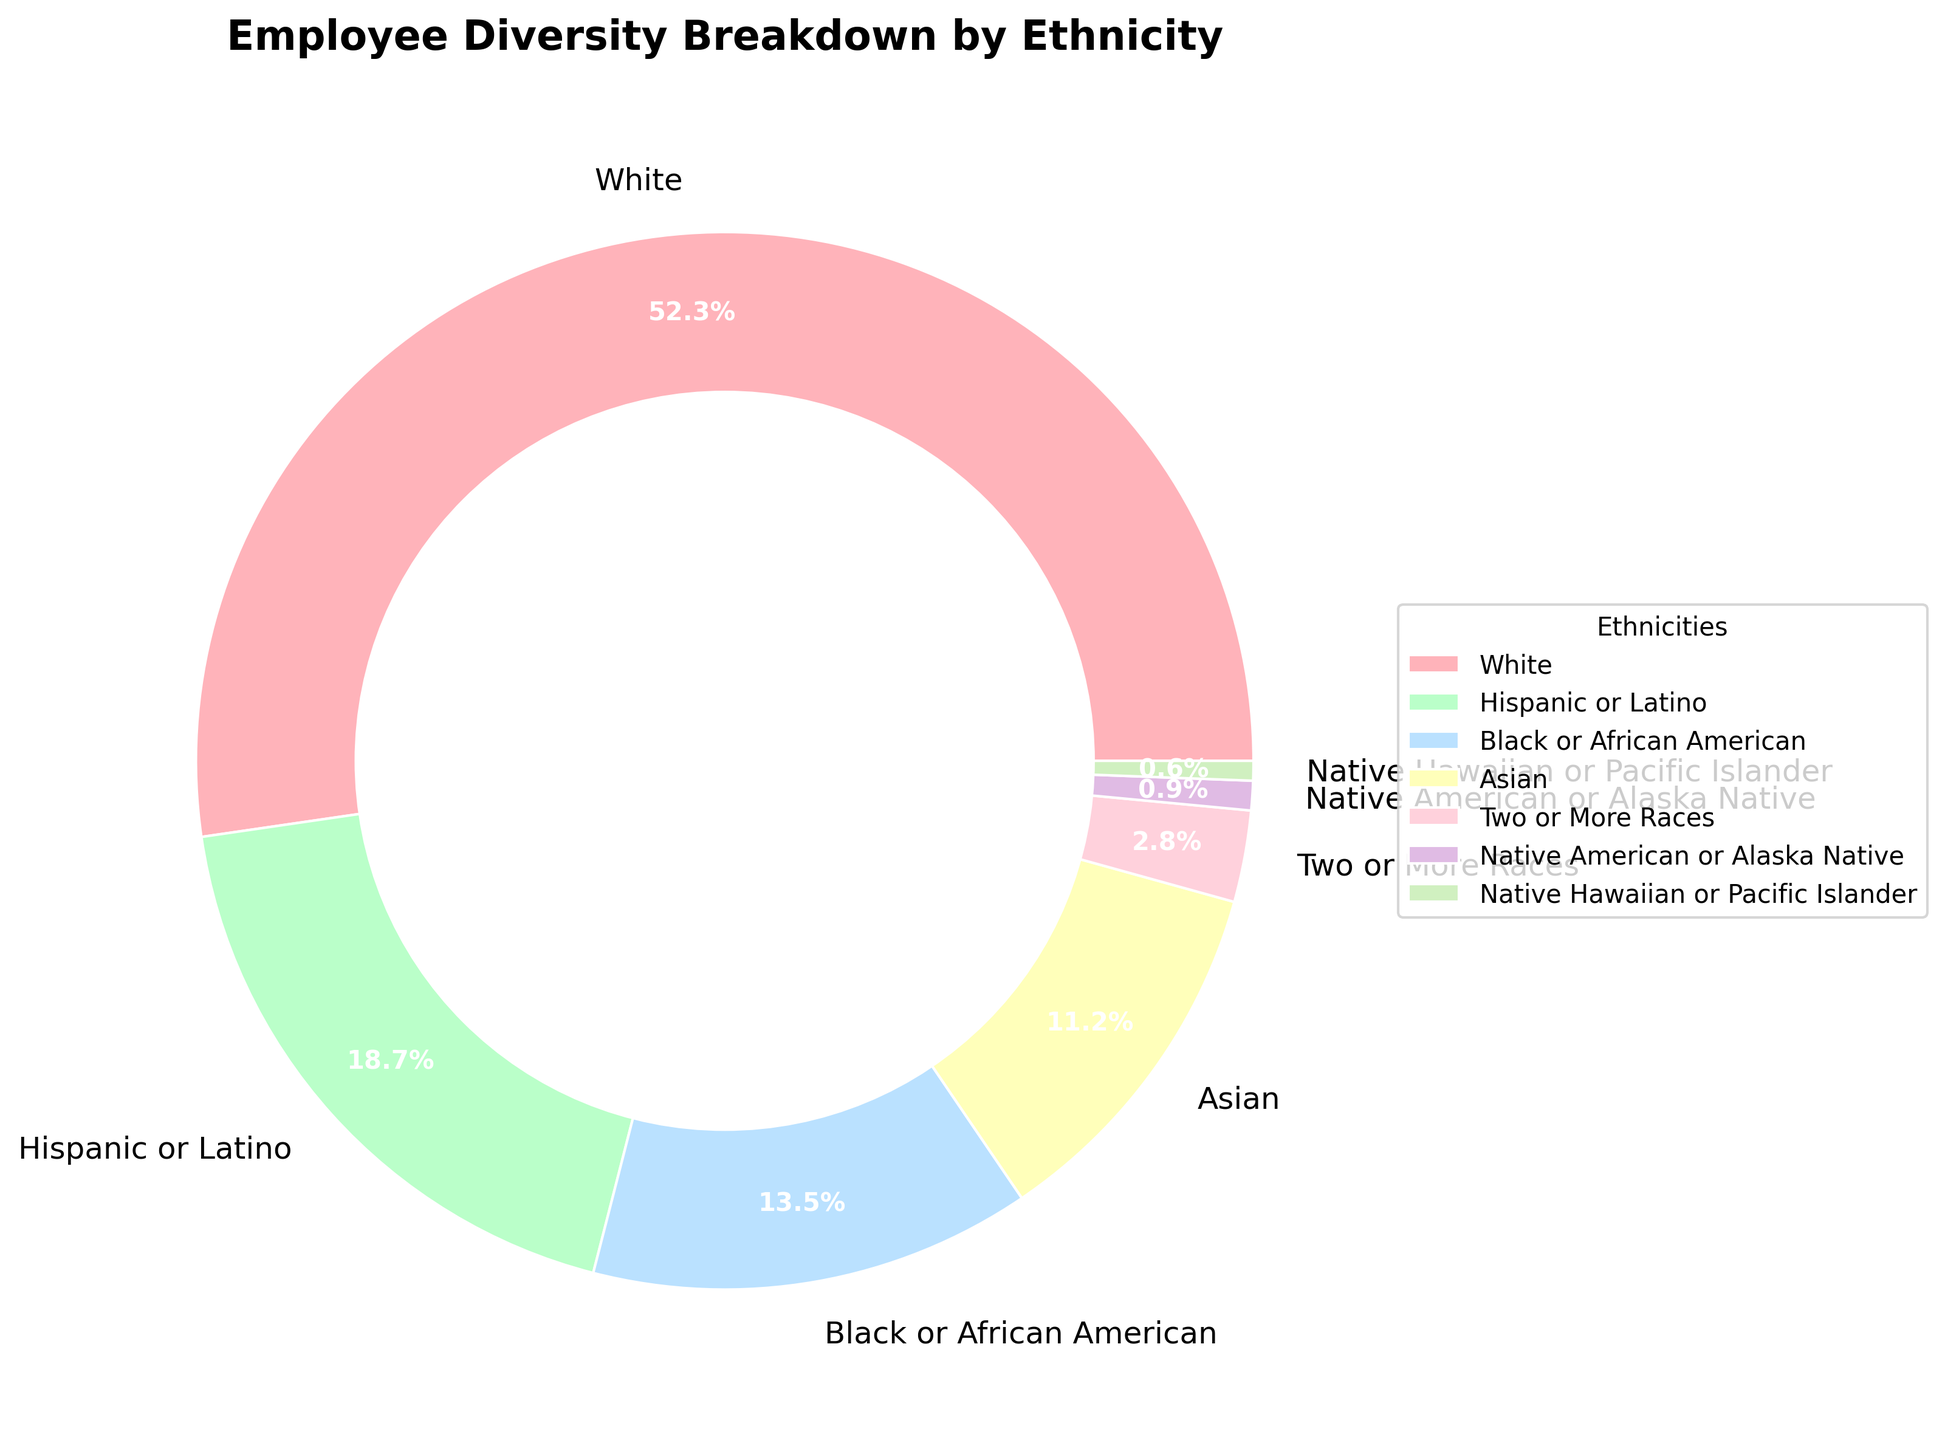What percentage of employees are either Asian or Black/African American? To find the total percentage of employees who are either Asian or Black/African American, we need to add their individual percentages. According to the chart, the percentage of Asian employees is 11.2%, and the percentage of Black/African American employees is 13.5%. Adding these together gives 11.2% + 13.5% = 24.7%.
Answer: 24.7% Which ethnic group has the second largest representation among employees? By examining the percentages of all ethnic groups, we see that White employees have the largest representation at 52.3%. The next largest group is Hispanic or Latino, with a representation of 18.7%.
Answer: Hispanic or Latino How many ethnic groups have a representation of less than 5%? Reviewing the chart, we find the percentages of ethnic groups as follows: Two or More Races (2.8%), Native American or Alaska Native (0.9%), and Native Hawaiian or Pacific Islander (0.6%) all have representation under 5%. In total, there are three groups under 5%.
Answer: 3 Is the percentage of White employees greater than the combined total of Hispanic or Latino and Black/African American employees? The percentage of White employees is 52.3%. The combined total of Hispanic or Latino (18.7%) and Black/African American (13.5%) employees is 18.7% + 13.5% = 32.2%. Since 52.3% is greater than 32.2%, the percentage of White employees is indeed higher.
Answer: Yes Does any ethnic group have exactly a tenth of the representation of White employees? The percentage of White employees is 52.3%. A tenth of this value would be 52.3/10 = 5.23%. No ethnic group has a representation of exactly 5.23%.
Answer: No 